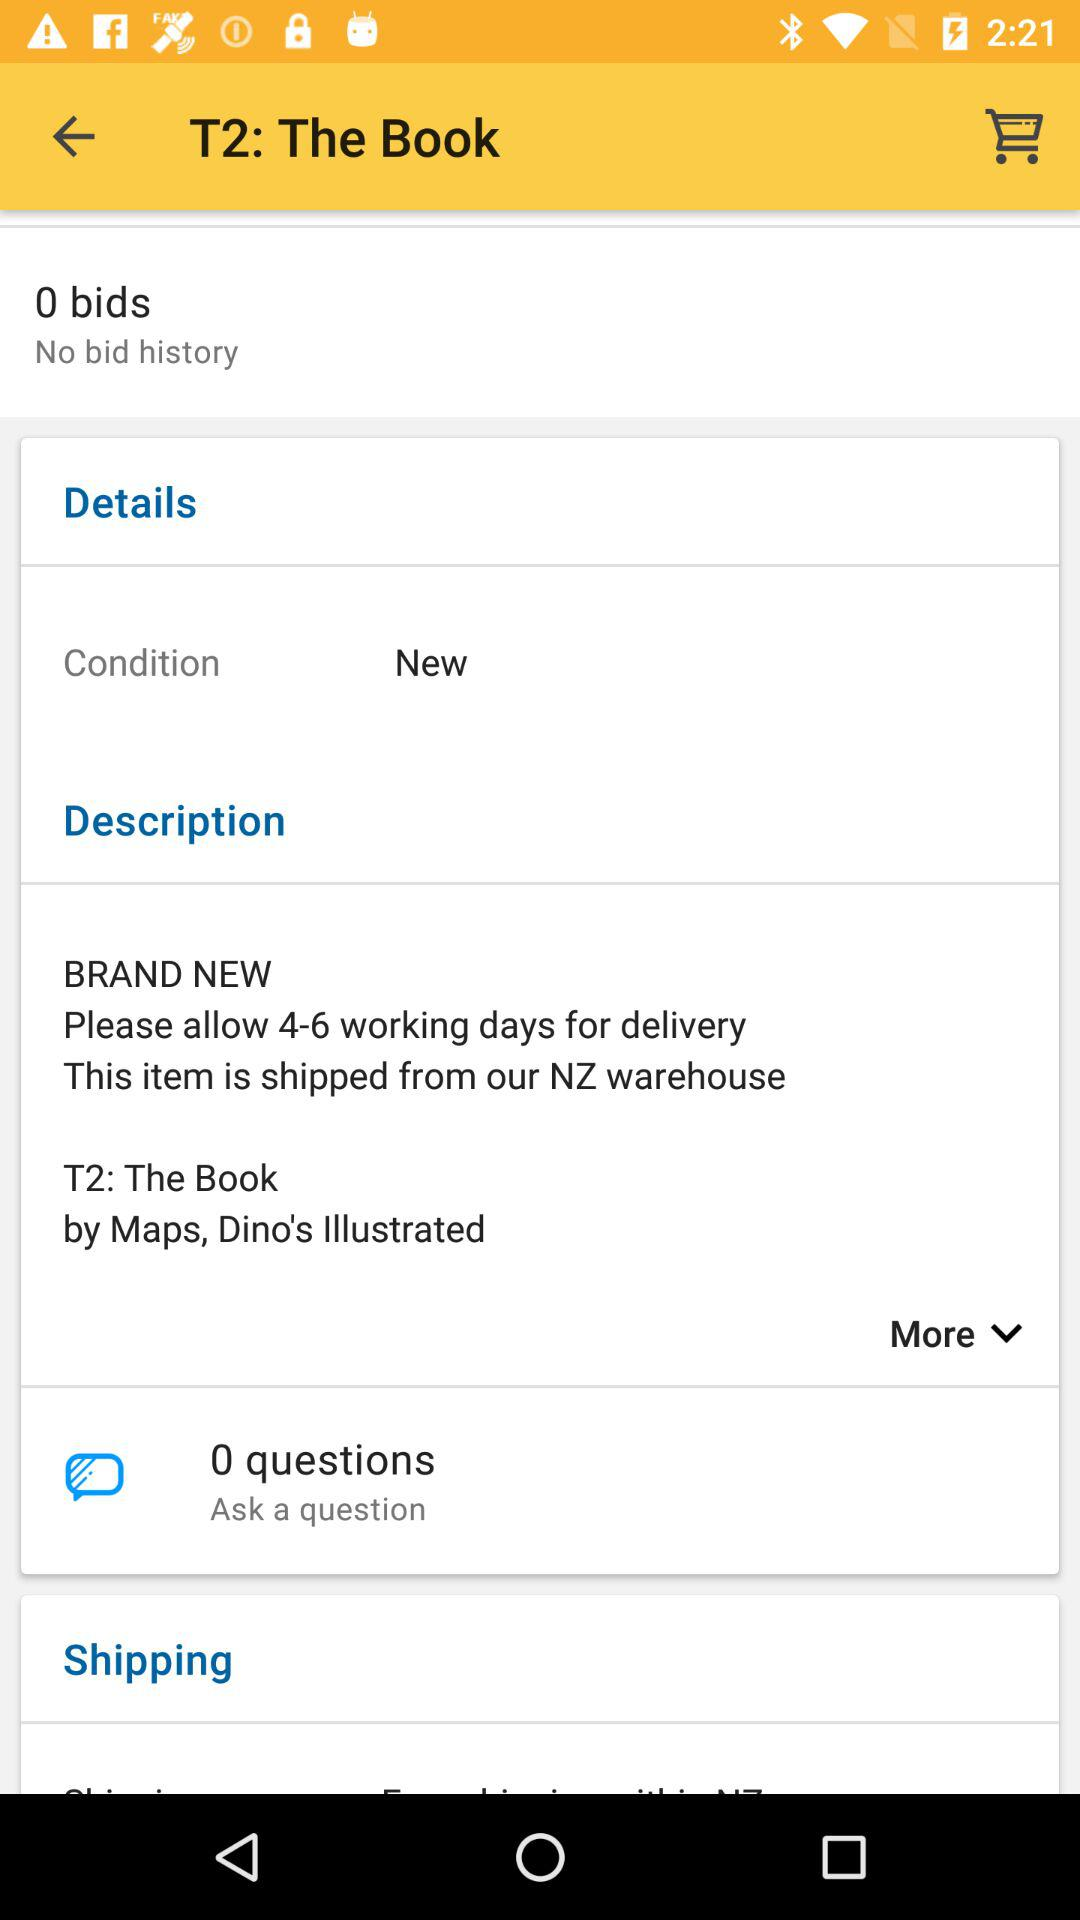What details are provided about the condition of the book listed? The book, titled 'T2: The Book', is listed as being in 'new' condition. 